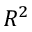<formula> <loc_0><loc_0><loc_500><loc_500>R ^ { 2 }</formula> 